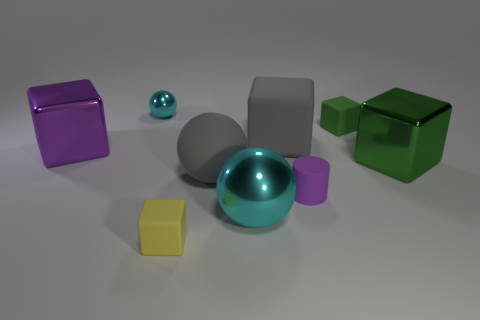If this image were part of an art installation, what theme do you think it might represent? If this image were part of an art installation, it could represent a theme of diversity and unity, showcasing different shapes, sizes, and textures coexisting harmoniously within a shared space. Alternatively, it could also evoke a theme of simplicity and minimalism, focusing on the beauty of basic geometric forms and muted colors. 